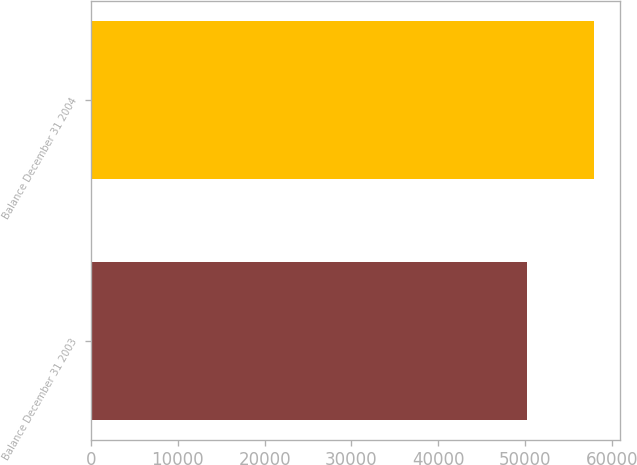Convert chart. <chart><loc_0><loc_0><loc_500><loc_500><bar_chart><fcel>Balance December 31 2003<fcel>Balance December 31 2004<nl><fcel>50198<fcel>58006<nl></chart> 